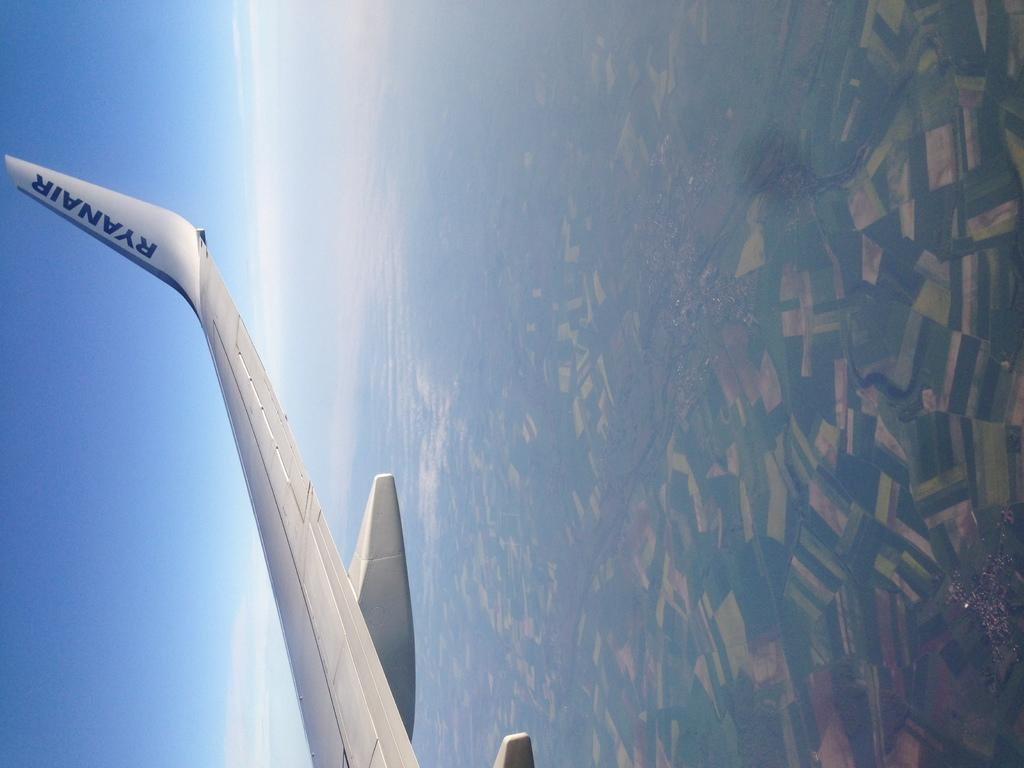<image>
Share a concise interpretation of the image provided. A tip of a wing of a Ryanair airplane is shown above the ground in flight. 